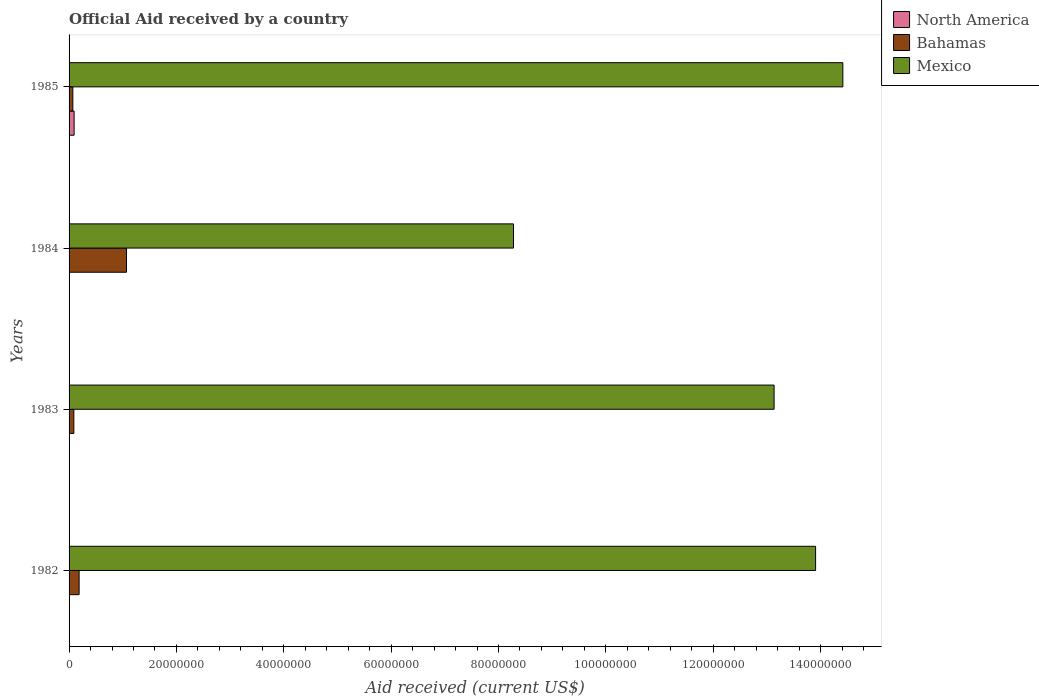How many different coloured bars are there?
Your answer should be compact. 3. Are the number of bars on each tick of the Y-axis equal?
Give a very brief answer. Yes. What is the net official aid received in Mexico in 1983?
Offer a terse response. 1.31e+08. Across all years, what is the maximum net official aid received in Bahamas?
Provide a short and direct response. 1.07e+07. Across all years, what is the minimum net official aid received in North America?
Give a very brief answer. 7.00e+04. In which year was the net official aid received in North America maximum?
Offer a very short reply. 1985. In which year was the net official aid received in Bahamas minimum?
Keep it short and to the point. 1985. What is the total net official aid received in North America in the graph?
Offer a very short reply. 1.16e+06. What is the difference between the net official aid received in Bahamas in 1983 and that in 1985?
Keep it short and to the point. 1.90e+05. What is the difference between the net official aid received in Mexico in 1984 and the net official aid received in Bahamas in 1982?
Give a very brief answer. 8.09e+07. What is the average net official aid received in Mexico per year?
Your answer should be very brief. 1.24e+08. In the year 1984, what is the difference between the net official aid received in Mexico and net official aid received in North America?
Offer a terse response. 8.27e+07. In how many years, is the net official aid received in Mexico greater than 132000000 US$?
Offer a very short reply. 2. What is the ratio of the net official aid received in North America in 1983 to that in 1985?
Make the answer very short. 0.07. Is the net official aid received in North America in 1984 less than that in 1985?
Ensure brevity in your answer.  Yes. Is the difference between the net official aid received in Mexico in 1984 and 1985 greater than the difference between the net official aid received in North America in 1984 and 1985?
Offer a terse response. No. What is the difference between the highest and the second highest net official aid received in North America?
Give a very brief answer. 8.60e+05. What is the difference between the highest and the lowest net official aid received in Mexico?
Keep it short and to the point. 6.14e+07. Is the sum of the net official aid received in North America in 1983 and 1985 greater than the maximum net official aid received in Mexico across all years?
Give a very brief answer. No. What does the 2nd bar from the top in 1984 represents?
Your answer should be very brief. Bahamas. What does the 3rd bar from the bottom in 1983 represents?
Keep it short and to the point. Mexico. Is it the case that in every year, the sum of the net official aid received in Bahamas and net official aid received in Mexico is greater than the net official aid received in North America?
Offer a terse response. Yes. How many bars are there?
Ensure brevity in your answer.  12. Are all the bars in the graph horizontal?
Give a very brief answer. Yes. How many years are there in the graph?
Your answer should be compact. 4. What is the difference between two consecutive major ticks on the X-axis?
Make the answer very short. 2.00e+07. Does the graph contain any zero values?
Your answer should be compact. No. Does the graph contain grids?
Provide a short and direct response. No. Where does the legend appear in the graph?
Offer a very short reply. Top right. How are the legend labels stacked?
Offer a terse response. Vertical. What is the title of the graph?
Provide a short and direct response. Official Aid received by a country. What is the label or title of the X-axis?
Ensure brevity in your answer.  Aid received (current US$). What is the Aid received (current US$) in North America in 1982?
Offer a very short reply. 7.00e+04. What is the Aid received (current US$) in Bahamas in 1982?
Offer a very short reply. 1.87e+06. What is the Aid received (current US$) of Mexico in 1982?
Your answer should be very brief. 1.39e+08. What is the Aid received (current US$) of Bahamas in 1983?
Offer a terse response. 8.90e+05. What is the Aid received (current US$) of Mexico in 1983?
Offer a terse response. 1.31e+08. What is the Aid received (current US$) of Bahamas in 1984?
Your answer should be compact. 1.07e+07. What is the Aid received (current US$) of Mexico in 1984?
Give a very brief answer. 8.28e+07. What is the Aid received (current US$) in North America in 1985?
Provide a short and direct response. 9.40e+05. What is the Aid received (current US$) of Mexico in 1985?
Provide a succinct answer. 1.44e+08. Across all years, what is the maximum Aid received (current US$) in North America?
Offer a terse response. 9.40e+05. Across all years, what is the maximum Aid received (current US$) of Bahamas?
Provide a succinct answer. 1.07e+07. Across all years, what is the maximum Aid received (current US$) of Mexico?
Keep it short and to the point. 1.44e+08. Across all years, what is the minimum Aid received (current US$) of North America?
Offer a very short reply. 7.00e+04. Across all years, what is the minimum Aid received (current US$) of Bahamas?
Your answer should be compact. 7.00e+05. Across all years, what is the minimum Aid received (current US$) of Mexico?
Your response must be concise. 8.28e+07. What is the total Aid received (current US$) in North America in the graph?
Offer a very short reply. 1.16e+06. What is the total Aid received (current US$) in Bahamas in the graph?
Provide a short and direct response. 1.42e+07. What is the total Aid received (current US$) in Mexico in the graph?
Make the answer very short. 4.97e+08. What is the difference between the Aid received (current US$) in North America in 1982 and that in 1983?
Provide a succinct answer. 0. What is the difference between the Aid received (current US$) of Bahamas in 1982 and that in 1983?
Provide a short and direct response. 9.80e+05. What is the difference between the Aid received (current US$) of Mexico in 1982 and that in 1983?
Ensure brevity in your answer.  7.73e+06. What is the difference between the Aid received (current US$) in North America in 1982 and that in 1984?
Offer a terse response. -10000. What is the difference between the Aid received (current US$) in Bahamas in 1982 and that in 1984?
Ensure brevity in your answer.  -8.83e+06. What is the difference between the Aid received (current US$) in Mexico in 1982 and that in 1984?
Offer a terse response. 5.63e+07. What is the difference between the Aid received (current US$) of North America in 1982 and that in 1985?
Provide a short and direct response. -8.70e+05. What is the difference between the Aid received (current US$) of Bahamas in 1982 and that in 1985?
Keep it short and to the point. 1.17e+06. What is the difference between the Aid received (current US$) in Mexico in 1982 and that in 1985?
Your answer should be very brief. -5.08e+06. What is the difference between the Aid received (current US$) in North America in 1983 and that in 1984?
Give a very brief answer. -10000. What is the difference between the Aid received (current US$) in Bahamas in 1983 and that in 1984?
Provide a short and direct response. -9.81e+06. What is the difference between the Aid received (current US$) of Mexico in 1983 and that in 1984?
Provide a succinct answer. 4.86e+07. What is the difference between the Aid received (current US$) in North America in 1983 and that in 1985?
Your response must be concise. -8.70e+05. What is the difference between the Aid received (current US$) in Mexico in 1983 and that in 1985?
Ensure brevity in your answer.  -1.28e+07. What is the difference between the Aid received (current US$) in North America in 1984 and that in 1985?
Ensure brevity in your answer.  -8.60e+05. What is the difference between the Aid received (current US$) in Mexico in 1984 and that in 1985?
Ensure brevity in your answer.  -6.14e+07. What is the difference between the Aid received (current US$) in North America in 1982 and the Aid received (current US$) in Bahamas in 1983?
Offer a terse response. -8.20e+05. What is the difference between the Aid received (current US$) of North America in 1982 and the Aid received (current US$) of Mexico in 1983?
Keep it short and to the point. -1.31e+08. What is the difference between the Aid received (current US$) in Bahamas in 1982 and the Aid received (current US$) in Mexico in 1983?
Provide a succinct answer. -1.29e+08. What is the difference between the Aid received (current US$) in North America in 1982 and the Aid received (current US$) in Bahamas in 1984?
Offer a terse response. -1.06e+07. What is the difference between the Aid received (current US$) in North America in 1982 and the Aid received (current US$) in Mexico in 1984?
Keep it short and to the point. -8.27e+07. What is the difference between the Aid received (current US$) in Bahamas in 1982 and the Aid received (current US$) in Mexico in 1984?
Provide a succinct answer. -8.09e+07. What is the difference between the Aid received (current US$) in North America in 1982 and the Aid received (current US$) in Bahamas in 1985?
Make the answer very short. -6.30e+05. What is the difference between the Aid received (current US$) of North America in 1982 and the Aid received (current US$) of Mexico in 1985?
Offer a very short reply. -1.44e+08. What is the difference between the Aid received (current US$) of Bahamas in 1982 and the Aid received (current US$) of Mexico in 1985?
Your answer should be very brief. -1.42e+08. What is the difference between the Aid received (current US$) in North America in 1983 and the Aid received (current US$) in Bahamas in 1984?
Give a very brief answer. -1.06e+07. What is the difference between the Aid received (current US$) in North America in 1983 and the Aid received (current US$) in Mexico in 1984?
Your answer should be compact. -8.27e+07. What is the difference between the Aid received (current US$) in Bahamas in 1983 and the Aid received (current US$) in Mexico in 1984?
Give a very brief answer. -8.19e+07. What is the difference between the Aid received (current US$) in North America in 1983 and the Aid received (current US$) in Bahamas in 1985?
Make the answer very short. -6.30e+05. What is the difference between the Aid received (current US$) in North America in 1983 and the Aid received (current US$) in Mexico in 1985?
Keep it short and to the point. -1.44e+08. What is the difference between the Aid received (current US$) of Bahamas in 1983 and the Aid received (current US$) of Mexico in 1985?
Make the answer very short. -1.43e+08. What is the difference between the Aid received (current US$) of North America in 1984 and the Aid received (current US$) of Bahamas in 1985?
Provide a short and direct response. -6.20e+05. What is the difference between the Aid received (current US$) of North America in 1984 and the Aid received (current US$) of Mexico in 1985?
Your answer should be very brief. -1.44e+08. What is the difference between the Aid received (current US$) of Bahamas in 1984 and the Aid received (current US$) of Mexico in 1985?
Keep it short and to the point. -1.33e+08. What is the average Aid received (current US$) of North America per year?
Provide a short and direct response. 2.90e+05. What is the average Aid received (current US$) in Bahamas per year?
Keep it short and to the point. 3.54e+06. What is the average Aid received (current US$) in Mexico per year?
Make the answer very short. 1.24e+08. In the year 1982, what is the difference between the Aid received (current US$) in North America and Aid received (current US$) in Bahamas?
Your answer should be very brief. -1.80e+06. In the year 1982, what is the difference between the Aid received (current US$) in North America and Aid received (current US$) in Mexico?
Offer a terse response. -1.39e+08. In the year 1982, what is the difference between the Aid received (current US$) in Bahamas and Aid received (current US$) in Mexico?
Offer a very short reply. -1.37e+08. In the year 1983, what is the difference between the Aid received (current US$) in North America and Aid received (current US$) in Bahamas?
Offer a very short reply. -8.20e+05. In the year 1983, what is the difference between the Aid received (current US$) in North America and Aid received (current US$) in Mexico?
Your answer should be very brief. -1.31e+08. In the year 1983, what is the difference between the Aid received (current US$) in Bahamas and Aid received (current US$) in Mexico?
Your response must be concise. -1.30e+08. In the year 1984, what is the difference between the Aid received (current US$) in North America and Aid received (current US$) in Bahamas?
Offer a very short reply. -1.06e+07. In the year 1984, what is the difference between the Aid received (current US$) in North America and Aid received (current US$) in Mexico?
Ensure brevity in your answer.  -8.27e+07. In the year 1984, what is the difference between the Aid received (current US$) in Bahamas and Aid received (current US$) in Mexico?
Your response must be concise. -7.21e+07. In the year 1985, what is the difference between the Aid received (current US$) in North America and Aid received (current US$) in Mexico?
Your answer should be compact. -1.43e+08. In the year 1985, what is the difference between the Aid received (current US$) in Bahamas and Aid received (current US$) in Mexico?
Ensure brevity in your answer.  -1.43e+08. What is the ratio of the Aid received (current US$) in Bahamas in 1982 to that in 1983?
Give a very brief answer. 2.1. What is the ratio of the Aid received (current US$) in Mexico in 1982 to that in 1983?
Offer a very short reply. 1.06. What is the ratio of the Aid received (current US$) in Bahamas in 1982 to that in 1984?
Offer a very short reply. 0.17. What is the ratio of the Aid received (current US$) of Mexico in 1982 to that in 1984?
Give a very brief answer. 1.68. What is the ratio of the Aid received (current US$) in North America in 1982 to that in 1985?
Provide a succinct answer. 0.07. What is the ratio of the Aid received (current US$) in Bahamas in 1982 to that in 1985?
Provide a short and direct response. 2.67. What is the ratio of the Aid received (current US$) of Mexico in 1982 to that in 1985?
Offer a very short reply. 0.96. What is the ratio of the Aid received (current US$) of North America in 1983 to that in 1984?
Provide a short and direct response. 0.88. What is the ratio of the Aid received (current US$) in Bahamas in 1983 to that in 1984?
Make the answer very short. 0.08. What is the ratio of the Aid received (current US$) in Mexico in 1983 to that in 1984?
Offer a terse response. 1.59. What is the ratio of the Aid received (current US$) in North America in 1983 to that in 1985?
Offer a very short reply. 0.07. What is the ratio of the Aid received (current US$) in Bahamas in 1983 to that in 1985?
Your answer should be very brief. 1.27. What is the ratio of the Aid received (current US$) of Mexico in 1983 to that in 1985?
Your response must be concise. 0.91. What is the ratio of the Aid received (current US$) in North America in 1984 to that in 1985?
Provide a short and direct response. 0.09. What is the ratio of the Aid received (current US$) of Bahamas in 1984 to that in 1985?
Your answer should be very brief. 15.29. What is the ratio of the Aid received (current US$) of Mexico in 1984 to that in 1985?
Give a very brief answer. 0.57. What is the difference between the highest and the second highest Aid received (current US$) in North America?
Offer a very short reply. 8.60e+05. What is the difference between the highest and the second highest Aid received (current US$) of Bahamas?
Your response must be concise. 8.83e+06. What is the difference between the highest and the second highest Aid received (current US$) in Mexico?
Make the answer very short. 5.08e+06. What is the difference between the highest and the lowest Aid received (current US$) of North America?
Your response must be concise. 8.70e+05. What is the difference between the highest and the lowest Aid received (current US$) in Mexico?
Your answer should be compact. 6.14e+07. 